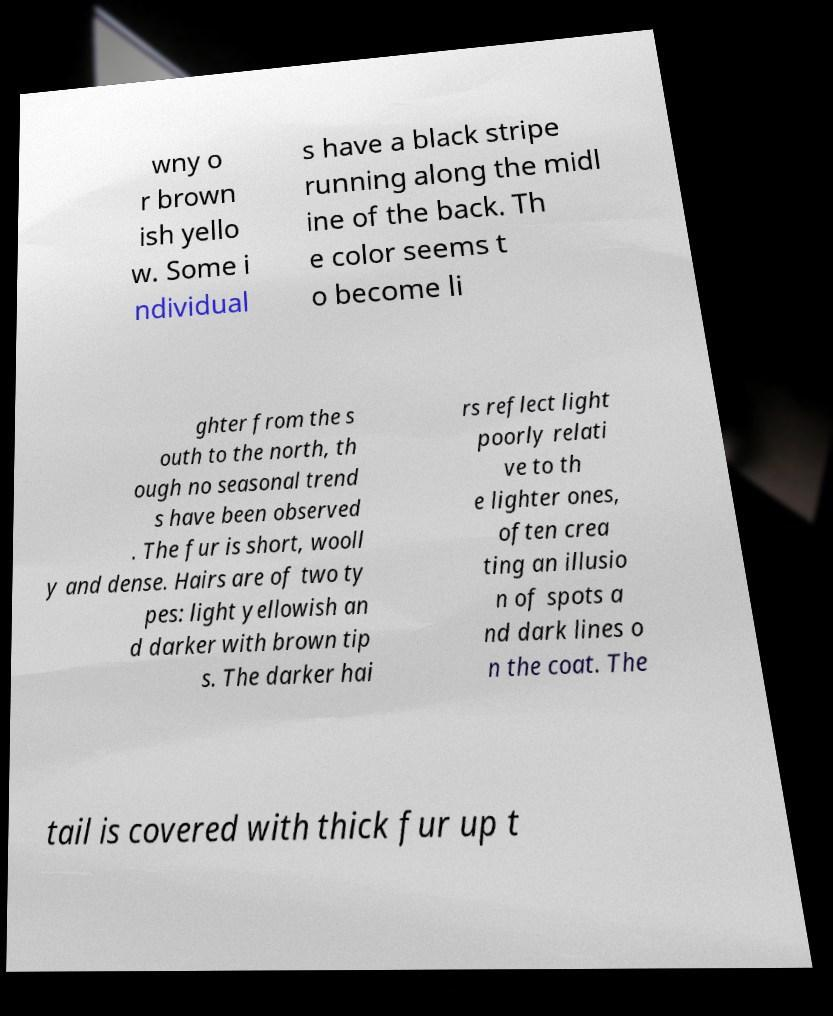Can you accurately transcribe the text from the provided image for me? wny o r brown ish yello w. Some i ndividual s have a black stripe running along the midl ine of the back. Th e color seems t o become li ghter from the s outh to the north, th ough no seasonal trend s have been observed . The fur is short, wooll y and dense. Hairs are of two ty pes: light yellowish an d darker with brown tip s. The darker hai rs reflect light poorly relati ve to th e lighter ones, often crea ting an illusio n of spots a nd dark lines o n the coat. The tail is covered with thick fur up t 